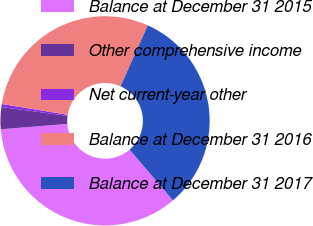<chart> <loc_0><loc_0><loc_500><loc_500><pie_chart><fcel>Balance at December 31 2015<fcel>Other comprehensive income<fcel>Net current-year other<fcel>Balance at December 31 2016<fcel>Balance at December 31 2017<nl><fcel>34.96%<fcel>3.39%<fcel>0.47%<fcel>29.13%<fcel>32.05%<nl></chart> 